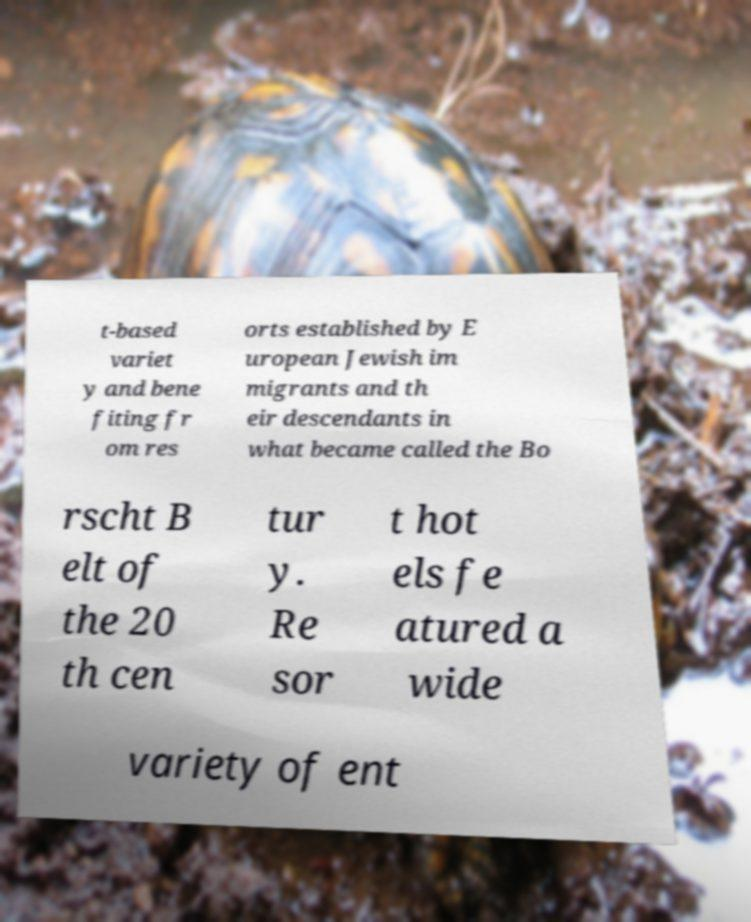For documentation purposes, I need the text within this image transcribed. Could you provide that? t-based variet y and bene fiting fr om res orts established by E uropean Jewish im migrants and th eir descendants in what became called the Bo rscht B elt of the 20 th cen tur y. Re sor t hot els fe atured a wide variety of ent 